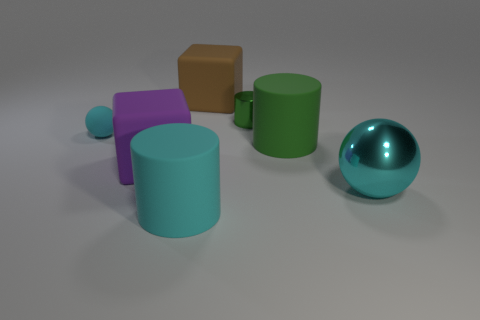There is a cyan shiny object; what shape is it?
Your response must be concise. Sphere. How many cubes are large purple objects or small yellow matte objects?
Provide a short and direct response. 1. Are there an equal number of small matte balls right of the cyan metallic thing and spheres that are on the right side of the purple cube?
Your response must be concise. No. What number of large cubes are to the right of the big cyan thing to the right of the large thing behind the large green matte cylinder?
Offer a terse response. 0. What shape is the big metal object that is the same color as the tiny matte thing?
Ensure brevity in your answer.  Sphere. There is a large shiny ball; is it the same color as the sphere that is left of the large cyan rubber object?
Offer a very short reply. Yes. Are there more cylinders behind the big cyan ball than brown blocks?
Your answer should be compact. Yes. What number of objects are either blocks behind the tiny cyan matte thing or matte objects behind the purple matte cube?
Your answer should be compact. 3. What is the size of the ball that is the same material as the large green cylinder?
Keep it short and to the point. Small. Does the big rubber object that is behind the tiny green metallic cylinder have the same shape as the tiny green thing?
Ensure brevity in your answer.  No. 